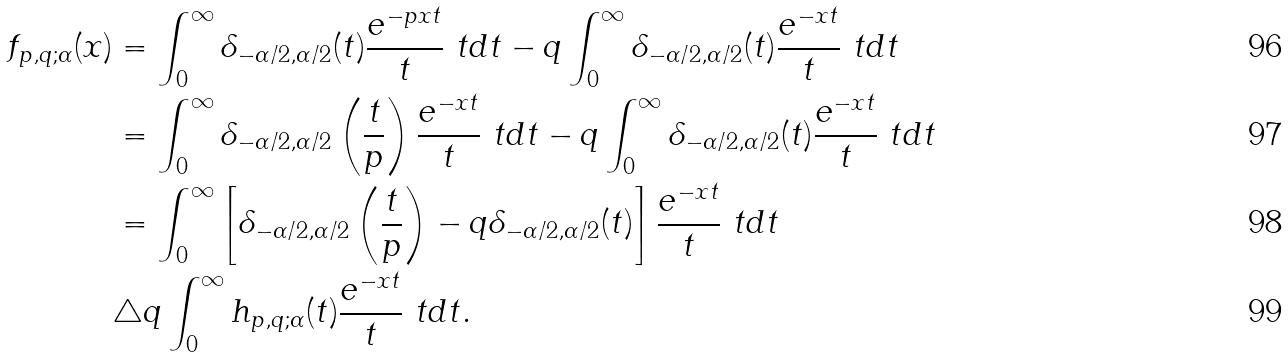<formula> <loc_0><loc_0><loc_500><loc_500>f _ { p , q ; \alpha } ( x ) & = \int _ { 0 } ^ { \infty } \delta _ { - \alpha / 2 , \alpha / 2 } ( t ) \frac { e ^ { - p x t } } { t } \ t d t - q \int _ { 0 } ^ { \infty } \delta _ { - \alpha / 2 , \alpha / 2 } ( t ) \frac { e ^ { - x t } } { t } \ t d t \\ & = \int _ { 0 } ^ { \infty } \delta _ { - \alpha / 2 , \alpha / 2 } \left ( \frac { t } p \right ) \frac { e ^ { - x t } } { t } \ t d t - q \int _ { 0 } ^ { \infty } \delta _ { - \alpha / 2 , \alpha / 2 } ( t ) \frac { e ^ { - x t } } { t } \ t d t \\ & = \int _ { 0 } ^ { \infty } \left [ \delta _ { - \alpha / 2 , \alpha / 2 } \left ( \frac { t } p \right ) - q \delta _ { - \alpha / 2 , \alpha / 2 } ( t ) \right ] \frac { e ^ { - x t } } { t } \ t d t \\ & \triangle q \int _ { 0 } ^ { \infty } h _ { p , q ; \alpha } ( t ) \frac { e ^ { - x t } } { t } \ t d t .</formula> 